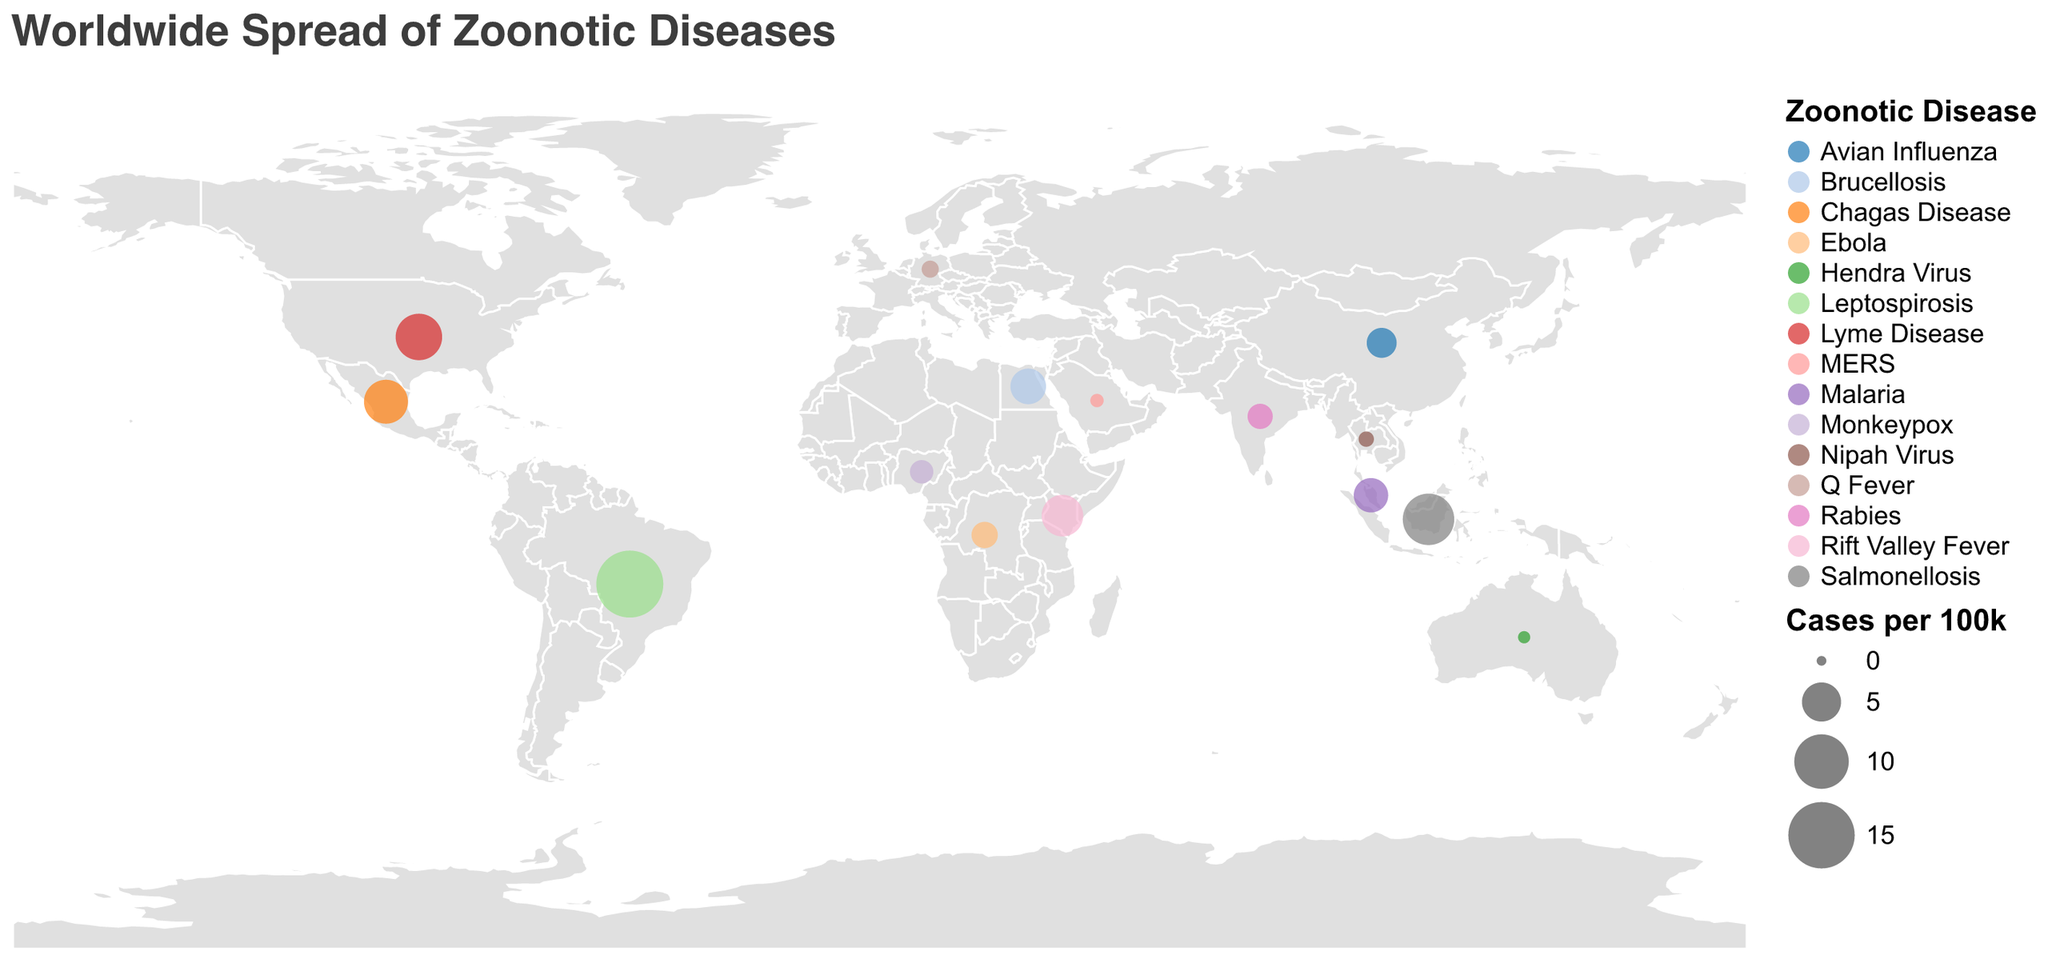What is the country with the highest cases per 100k for zoonotic diseases? By looking at the sizes of the circles on the map, the largest circle represents the country with the highest cases per 100k for zoonotic diseases. In this case, Brazil has the largest circle.
Answer: Brazil How many countries have more than 5 cases per 100k? Identify the countries with a circle size that indicates more than 5 cases per 100k (select those with cases_per_100k > 5). These countries are Brazil, Kenya, Mexico, and Indonesia. Count these countries.
Answer: 4 Which zoonotic disease has the most widespread geographic distribution? By observing the color coding for each disease on the map and seeing which color appears in the most locations, the most universally distributed disease can be identified. Lyme Disease (marked in green) appears extensively across multiple continents.
Answer: Lyme Disease What is the relationship between human-animal interaction types and the countries affected by Avian Influenza? Identify and count the total number of countries affected by Avian Influenza, noting the specific interactions majorly linked to poultry farming.
Answer: Human-animal interaction for Avian Influenza is predominantly linked to poultry farming and largely affects China Compare the number of cases per 100k for zoonotic diseases in Brazil and Mexico. Which country has more cases? Identify the cases_per_100k for Brazil and Mexico by observing the size of their respective circles. Brazil has 15.3 cases per 100k, whereas Mexico has 6.4 cases per 100k.
Answer: Brazil Which country in Africa shows high cases of Rift Valley Fever due to livestock farming? Pinpoint the African countries on the map and the specific zoonotic diseases they are marked with. Kenya shows high cases of Rift Valley Fever connected to livestock farming.
Answer: Kenya What are the differences in zoonotic disease cases between countries with fruit bat-related interactions? Observe the cases per 100k for Australia and the Democratic Republic of Congo connected to Hendra Virus and Ebola respectively, both relating to fruit bat interactions. Australia has 0.2 cases per 100k while the Democratic Republic of Congo has 2.1 cases per 100k.
Answer: Australia has lower cases than the Democratic Republic of Congo How does the case rate of zoonotic diseases in Indonesia compare to other countries in Southeast Asia? Identify the case rates of zoonotic diseases in countries in Southeast Asia like Indonesia, Malaysia, and Thailand. Indonesia has 8.9, Malaysia has 3.8, and Thailand has 0.5 cases per 100k.
Answer: Indonesia has the highest cases Identify countries affected by zoonotic diseases due to dairy production. Locate and count the countries marked with the legend corresponding to dairy production interaction. The only country fitting this criterion is Egypt.
Answer: Egypt Which countries have zoonotic disease outbreaks specifically linked to deforestation activities? Observe the map for regions where the legend indicates deforestation as the cause for zoonotic diseases. The country marked is Malaysia.
Answer: Malaysia 